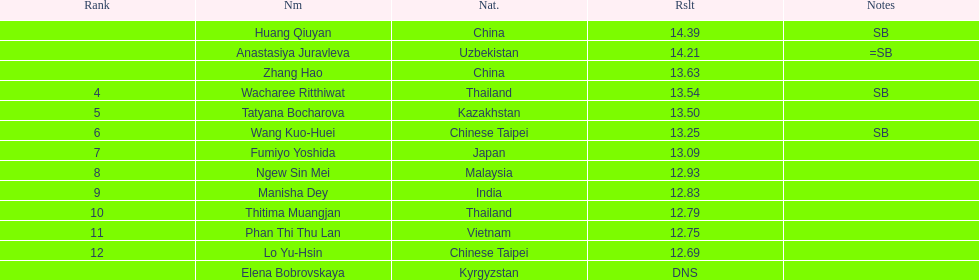How many athletes had a better result than tatyana bocharova? 4. 